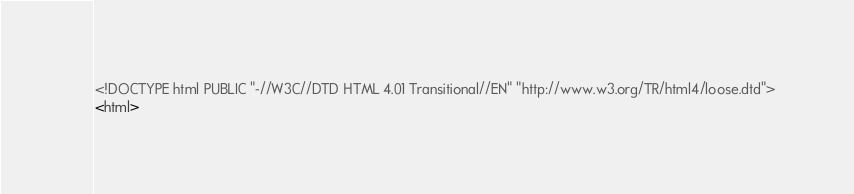<code> <loc_0><loc_0><loc_500><loc_500><_HTML_><!DOCTYPE html PUBLIC "-//W3C//DTD HTML 4.01 Transitional//EN" "http://www.w3.org/TR/html4/loose.dtd">
<html></code> 